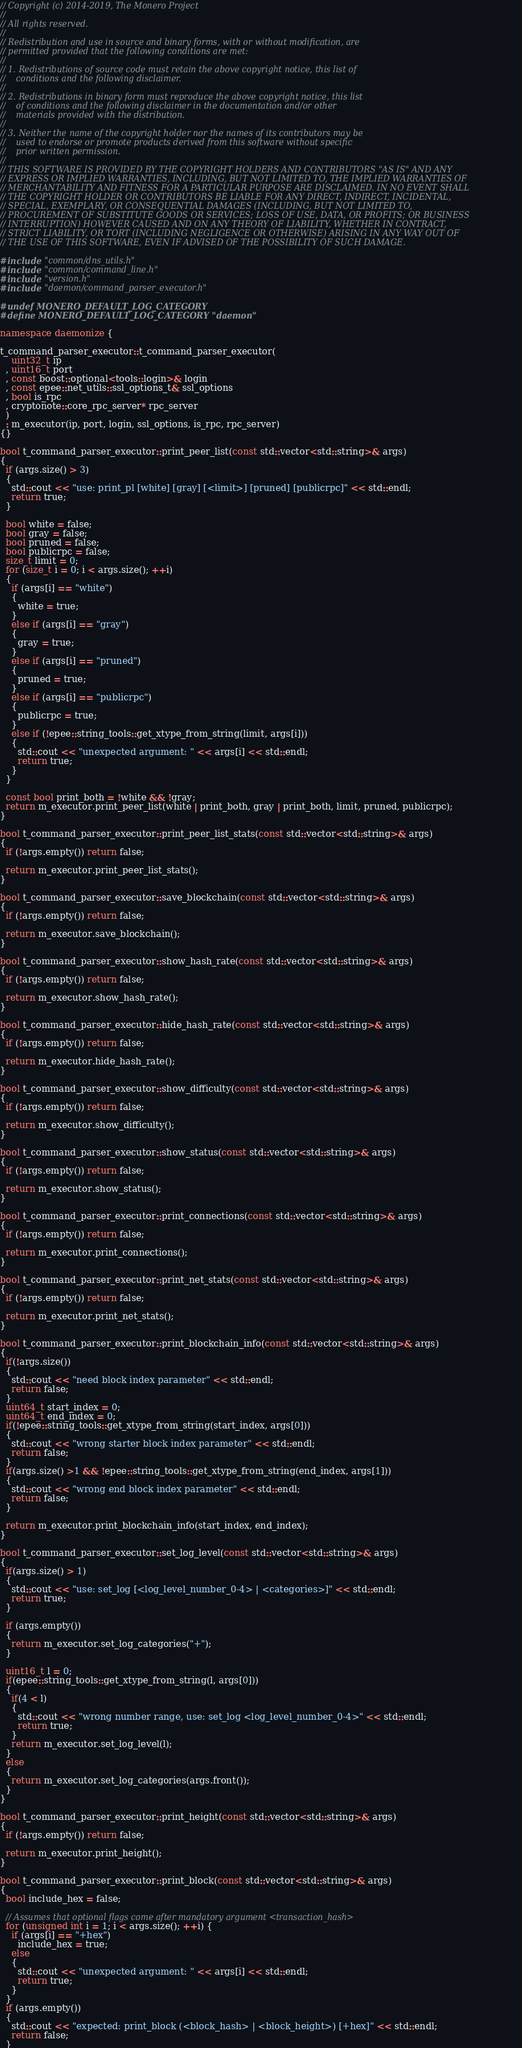<code> <loc_0><loc_0><loc_500><loc_500><_C++_>// Copyright (c) 2014-2019, The Monero Project
// 
// All rights reserved.
// 
// Redistribution and use in source and binary forms, with or without modification, are
// permitted provided that the following conditions are met:
// 
// 1. Redistributions of source code must retain the above copyright notice, this list of
//    conditions and the following disclaimer.
// 
// 2. Redistributions in binary form must reproduce the above copyright notice, this list
//    of conditions and the following disclaimer in the documentation and/or other
//    materials provided with the distribution.
// 
// 3. Neither the name of the copyright holder nor the names of its contributors may be
//    used to endorse or promote products derived from this software without specific
//    prior written permission.
// 
// THIS SOFTWARE IS PROVIDED BY THE COPYRIGHT HOLDERS AND CONTRIBUTORS "AS IS" AND ANY
// EXPRESS OR IMPLIED WARRANTIES, INCLUDING, BUT NOT LIMITED TO, THE IMPLIED WARRANTIES OF
// MERCHANTABILITY AND FITNESS FOR A PARTICULAR PURPOSE ARE DISCLAIMED. IN NO EVENT SHALL
// THE COPYRIGHT HOLDER OR CONTRIBUTORS BE LIABLE FOR ANY DIRECT, INDIRECT, INCIDENTAL,
// SPECIAL, EXEMPLARY, OR CONSEQUENTIAL DAMAGES (INCLUDING, BUT NOT LIMITED TO,
// PROCUREMENT OF SUBSTITUTE GOODS OR SERVICES; LOSS OF USE, DATA, OR PROFITS; OR BUSINESS
// INTERRUPTION) HOWEVER CAUSED AND ON ANY THEORY OF LIABILITY, WHETHER IN CONTRACT,
// STRICT LIABILITY, OR TORT (INCLUDING NEGLIGENCE OR OTHERWISE) ARISING IN ANY WAY OUT OF
// THE USE OF THIS SOFTWARE, EVEN IF ADVISED OF THE POSSIBILITY OF SUCH DAMAGE.

#include "common/dns_utils.h"
#include "common/command_line.h"
#include "version.h"
#include "daemon/command_parser_executor.h"

#undef MONERO_DEFAULT_LOG_CATEGORY
#define MONERO_DEFAULT_LOG_CATEGORY "daemon"

namespace daemonize {

t_command_parser_executor::t_command_parser_executor(
    uint32_t ip
  , uint16_t port
  , const boost::optional<tools::login>& login
  , const epee::net_utils::ssl_options_t& ssl_options
  , bool is_rpc
  , cryptonote::core_rpc_server* rpc_server
  )
  : m_executor(ip, port, login, ssl_options, is_rpc, rpc_server)
{}

bool t_command_parser_executor::print_peer_list(const std::vector<std::string>& args)
{
  if (args.size() > 3)
  {
    std::cout << "use: print_pl [white] [gray] [<limit>] [pruned] [publicrpc]" << std::endl;
    return true;
  }

  bool white = false;
  bool gray = false;
  bool pruned = false;
  bool publicrpc = false;
  size_t limit = 0;
  for (size_t i = 0; i < args.size(); ++i)
  {
    if (args[i] == "white")
    {
      white = true;
    }
    else if (args[i] == "gray")
    {
      gray = true;
    }
    else if (args[i] == "pruned")
    {
      pruned = true;
    }
    else if (args[i] == "publicrpc")
    {
      publicrpc = true;
    }
    else if (!epee::string_tools::get_xtype_from_string(limit, args[i]))
    {
      std::cout << "unexpected argument: " << args[i] << std::endl;
      return true;
    }
  }

  const bool print_both = !white && !gray;
  return m_executor.print_peer_list(white | print_both, gray | print_both, limit, pruned, publicrpc);
}

bool t_command_parser_executor::print_peer_list_stats(const std::vector<std::string>& args)
{
  if (!args.empty()) return false;

  return m_executor.print_peer_list_stats();
}

bool t_command_parser_executor::save_blockchain(const std::vector<std::string>& args)
{
  if (!args.empty()) return false;

  return m_executor.save_blockchain();
}

bool t_command_parser_executor::show_hash_rate(const std::vector<std::string>& args)
{
  if (!args.empty()) return false;

  return m_executor.show_hash_rate();
}

bool t_command_parser_executor::hide_hash_rate(const std::vector<std::string>& args)
{
  if (!args.empty()) return false;

  return m_executor.hide_hash_rate();
}

bool t_command_parser_executor::show_difficulty(const std::vector<std::string>& args)
{
  if (!args.empty()) return false;

  return m_executor.show_difficulty();
}

bool t_command_parser_executor::show_status(const std::vector<std::string>& args)
{
  if (!args.empty()) return false;

  return m_executor.show_status();
}

bool t_command_parser_executor::print_connections(const std::vector<std::string>& args)
{
  if (!args.empty()) return false;

  return m_executor.print_connections();
}

bool t_command_parser_executor::print_net_stats(const std::vector<std::string>& args)
{
  if (!args.empty()) return false;

  return m_executor.print_net_stats();
}

bool t_command_parser_executor::print_blockchain_info(const std::vector<std::string>& args)
{
  if(!args.size())
  {
    std::cout << "need block index parameter" << std::endl;
    return false;
  }
  uint64_t start_index = 0;
  uint64_t end_index = 0;
  if(!epee::string_tools::get_xtype_from_string(start_index, args[0]))
  {
    std::cout << "wrong starter block index parameter" << std::endl;
    return false;
  }
  if(args.size() >1 && !epee::string_tools::get_xtype_from_string(end_index, args[1]))
  {
    std::cout << "wrong end block index parameter" << std::endl;
    return false;
  }

  return m_executor.print_blockchain_info(start_index, end_index);
}

bool t_command_parser_executor::set_log_level(const std::vector<std::string>& args)
{
  if(args.size() > 1)
  {
    std::cout << "use: set_log [<log_level_number_0-4> | <categories>]" << std::endl;
    return true;
  }

  if (args.empty())
  {
    return m_executor.set_log_categories("+");
  }

  uint16_t l = 0;
  if(epee::string_tools::get_xtype_from_string(l, args[0]))
  {
    if(4 < l)
    {
      std::cout << "wrong number range, use: set_log <log_level_number_0-4>" << std::endl;
      return true;
    }
    return m_executor.set_log_level(l);
  }
  else
  {
    return m_executor.set_log_categories(args.front());
  }
}

bool t_command_parser_executor::print_height(const std::vector<std::string>& args) 
{
  if (!args.empty()) return false;

  return m_executor.print_height();
}

bool t_command_parser_executor::print_block(const std::vector<std::string>& args)
{
  bool include_hex = false;

  // Assumes that optional flags come after mandatory argument <transaction_hash>
  for (unsigned int i = 1; i < args.size(); ++i) {
    if (args[i] == "+hex")
      include_hex = true;
    else
    {
      std::cout << "unexpected argument: " << args[i] << std::endl;
      return true;
    }
  }
  if (args.empty())
  {
    std::cout << "expected: print_block (<block_hash> | <block_height>) [+hex]" << std::endl;
    return false;
  }
</code> 